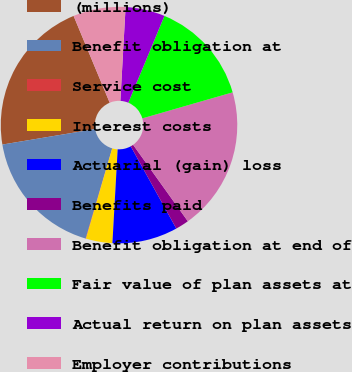Convert chart to OTSL. <chart><loc_0><loc_0><loc_500><loc_500><pie_chart><fcel>(millions)<fcel>Benefit obligation at<fcel>Service cost<fcel>Interest costs<fcel>Actuarial (gain) loss<fcel>Benefits paid<fcel>Benefit obligation at end of<fcel>Fair value of plan assets at<fcel>Actual return on plan assets<fcel>Employer contributions<nl><fcel>21.36%<fcel>17.81%<fcel>0.06%<fcel>3.61%<fcel>8.94%<fcel>1.84%<fcel>19.58%<fcel>14.26%<fcel>5.39%<fcel>7.16%<nl></chart> 